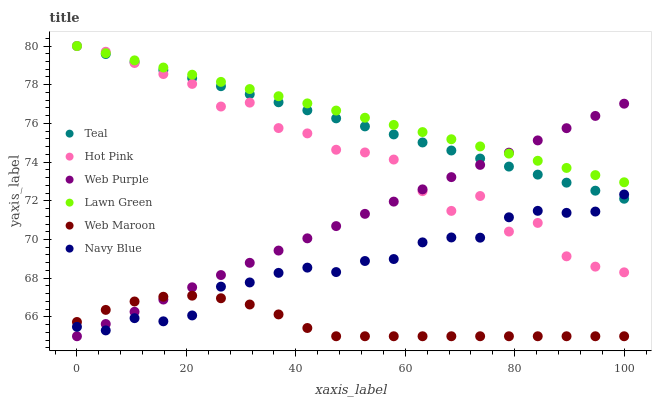Does Web Maroon have the minimum area under the curve?
Answer yes or no. Yes. Does Lawn Green have the maximum area under the curve?
Answer yes or no. Yes. Does Navy Blue have the minimum area under the curve?
Answer yes or no. No. Does Navy Blue have the maximum area under the curve?
Answer yes or no. No. Is Web Purple the smoothest?
Answer yes or no. Yes. Is Hot Pink the roughest?
Answer yes or no. Yes. Is Navy Blue the smoothest?
Answer yes or no. No. Is Navy Blue the roughest?
Answer yes or no. No. Does Web Maroon have the lowest value?
Answer yes or no. Yes. Does Navy Blue have the lowest value?
Answer yes or no. No. Does Teal have the highest value?
Answer yes or no. Yes. Does Navy Blue have the highest value?
Answer yes or no. No. Is Navy Blue less than Lawn Green?
Answer yes or no. Yes. Is Lawn Green greater than Web Maroon?
Answer yes or no. Yes. Does Web Purple intersect Web Maroon?
Answer yes or no. Yes. Is Web Purple less than Web Maroon?
Answer yes or no. No. Is Web Purple greater than Web Maroon?
Answer yes or no. No. Does Navy Blue intersect Lawn Green?
Answer yes or no. No. 